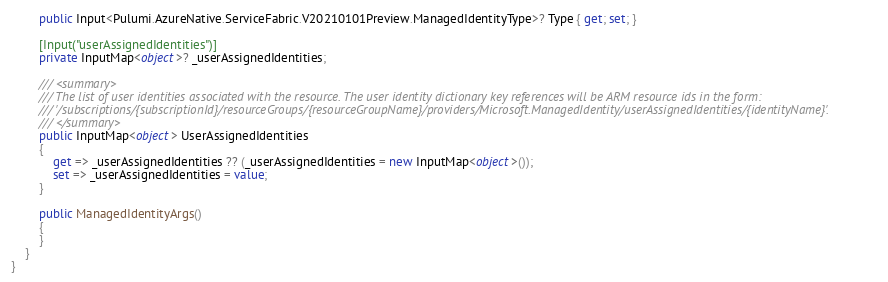Convert code to text. <code><loc_0><loc_0><loc_500><loc_500><_C#_>        public Input<Pulumi.AzureNative.ServiceFabric.V20210101Preview.ManagedIdentityType>? Type { get; set; }

        [Input("userAssignedIdentities")]
        private InputMap<object>? _userAssignedIdentities;

        /// <summary>
        /// The list of user identities associated with the resource. The user identity dictionary key references will be ARM resource ids in the form:
        /// '/subscriptions/{subscriptionId}/resourceGroups/{resourceGroupName}/providers/Microsoft.ManagedIdentity/userAssignedIdentities/{identityName}'.
        /// </summary>
        public InputMap<object> UserAssignedIdentities
        {
            get => _userAssignedIdentities ?? (_userAssignedIdentities = new InputMap<object>());
            set => _userAssignedIdentities = value;
        }

        public ManagedIdentityArgs()
        {
        }
    }
}
</code> 